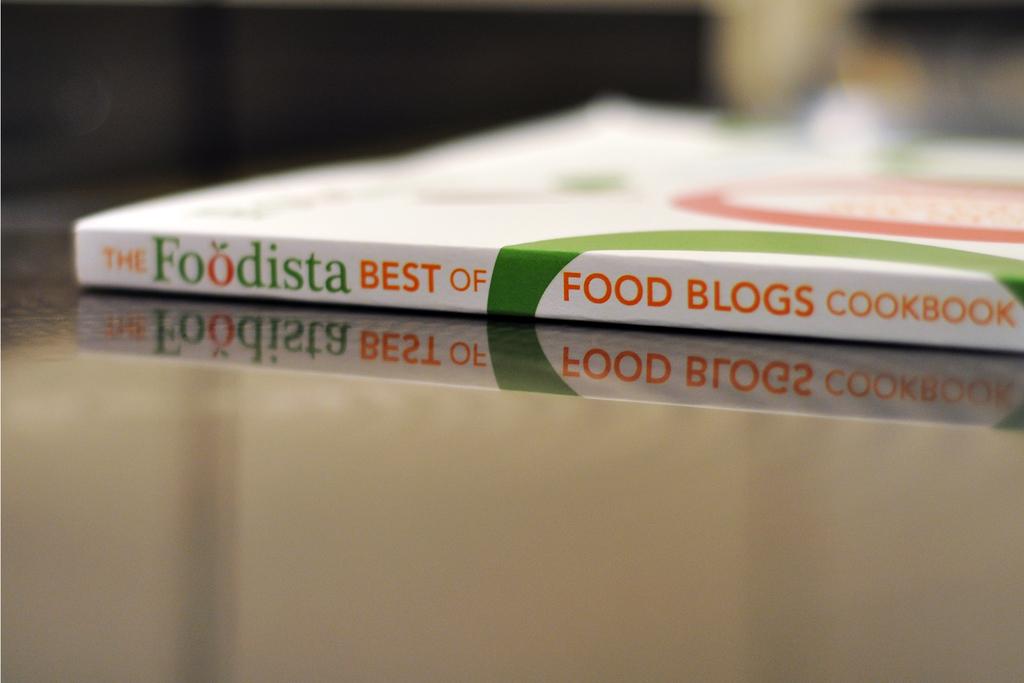What is the name of a food blog cookbook?
Provide a succinct answer. The foodista. 